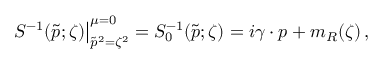Convert formula to latex. <formula><loc_0><loc_0><loc_500><loc_500>S ^ { - 1 } ( \tilde { p } ; \zeta ) \right | _ { \tilde { p } ^ { 2 } = \zeta ^ { 2 } } ^ { \mu = 0 } = S _ { 0 } ^ { - 1 } ( \tilde { p } ; \zeta ) = i \gamma \cdot p + m _ { R } ( \zeta ) \, ,</formula> 